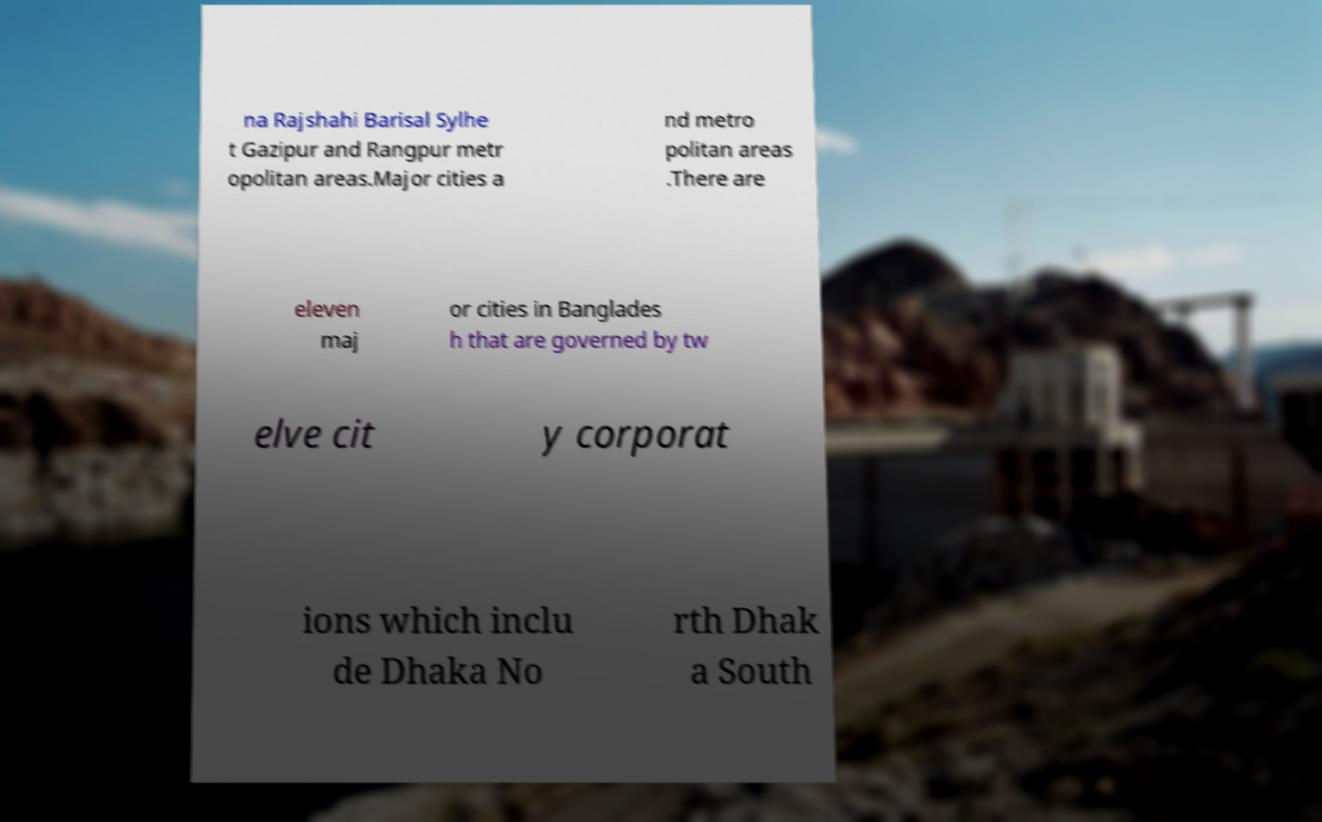Could you extract and type out the text from this image? na Rajshahi Barisal Sylhe t Gazipur and Rangpur metr opolitan areas.Major cities a nd metro politan areas .There are eleven maj or cities in Banglades h that are governed by tw elve cit y corporat ions which inclu de Dhaka No rth Dhak a South 